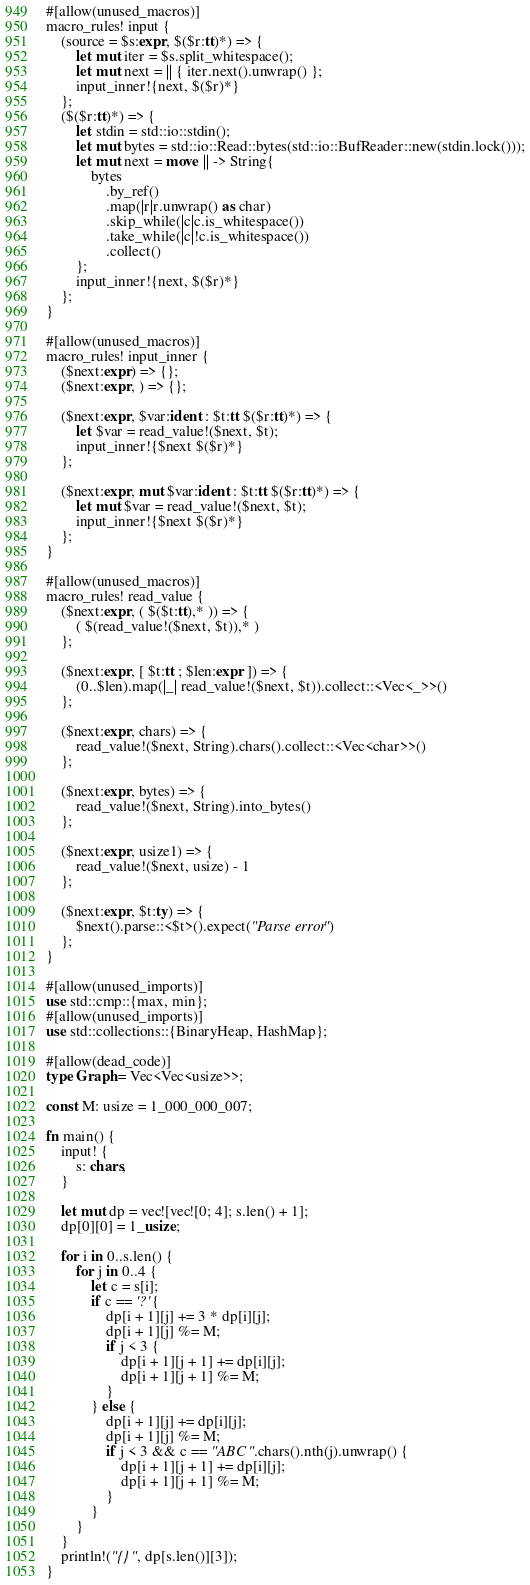Convert code to text. <code><loc_0><loc_0><loc_500><loc_500><_Rust_>#[allow(unused_macros)]
macro_rules! input {
    (source = $s:expr, $($r:tt)*) => {
        let mut iter = $s.split_whitespace();
        let mut next = || { iter.next().unwrap() };
        input_inner!{next, $($r)*}
    };
    ($($r:tt)*) => {
        let stdin = std::io::stdin();
        let mut bytes = std::io::Read::bytes(std::io::BufReader::new(stdin.lock()));
        let mut next = move || -> String{
            bytes
                .by_ref()
                .map(|r|r.unwrap() as char)
                .skip_while(|c|c.is_whitespace())
                .take_while(|c|!c.is_whitespace())
                .collect()
        };
        input_inner!{next, $($r)*}
    };
}

#[allow(unused_macros)]
macro_rules! input_inner {
    ($next:expr) => {};
    ($next:expr, ) => {};

    ($next:expr, $var:ident : $t:tt $($r:tt)*) => {
        let $var = read_value!($next, $t);
        input_inner!{$next $($r)*}
    };

    ($next:expr, mut $var:ident : $t:tt $($r:tt)*) => {
        let mut $var = read_value!($next, $t);
        input_inner!{$next $($r)*}
    };
}

#[allow(unused_macros)]
macro_rules! read_value {
    ($next:expr, ( $($t:tt),* )) => {
        ( $(read_value!($next, $t)),* )
    };

    ($next:expr, [ $t:tt ; $len:expr ]) => {
        (0..$len).map(|_| read_value!($next, $t)).collect::<Vec<_>>()
    };

    ($next:expr, chars) => {
        read_value!($next, String).chars().collect::<Vec<char>>()
    };

    ($next:expr, bytes) => {
        read_value!($next, String).into_bytes()
    };

    ($next:expr, usize1) => {
        read_value!($next, usize) - 1
    };

    ($next:expr, $t:ty) => {
        $next().parse::<$t>().expect("Parse error")
    };
}

#[allow(unused_imports)]
use std::cmp::{max, min};
#[allow(unused_imports)]
use std::collections::{BinaryHeap, HashMap};

#[allow(dead_code)]
type Graph = Vec<Vec<usize>>;

const M: usize = 1_000_000_007;

fn main() {
    input! {
        s: chars,
    }

    let mut dp = vec![vec![0; 4]; s.len() + 1];
    dp[0][0] = 1_usize;

    for i in 0..s.len() {
        for j in 0..4 {
            let c = s[i];
            if c == '?' {
                dp[i + 1][j] += 3 * dp[i][j];
                dp[i + 1][j] %= M;
                if j < 3 {
                    dp[i + 1][j + 1] += dp[i][j];
                    dp[i + 1][j + 1] %= M;
                }
            } else {
                dp[i + 1][j] += dp[i][j];
                dp[i + 1][j] %= M;
                if j < 3 && c == "ABC".chars().nth(j).unwrap() {
                    dp[i + 1][j + 1] += dp[i][j];
                    dp[i + 1][j + 1] %= M;
                }
            }
        }
    }
    println!("{}", dp[s.len()][3]);
}
</code> 